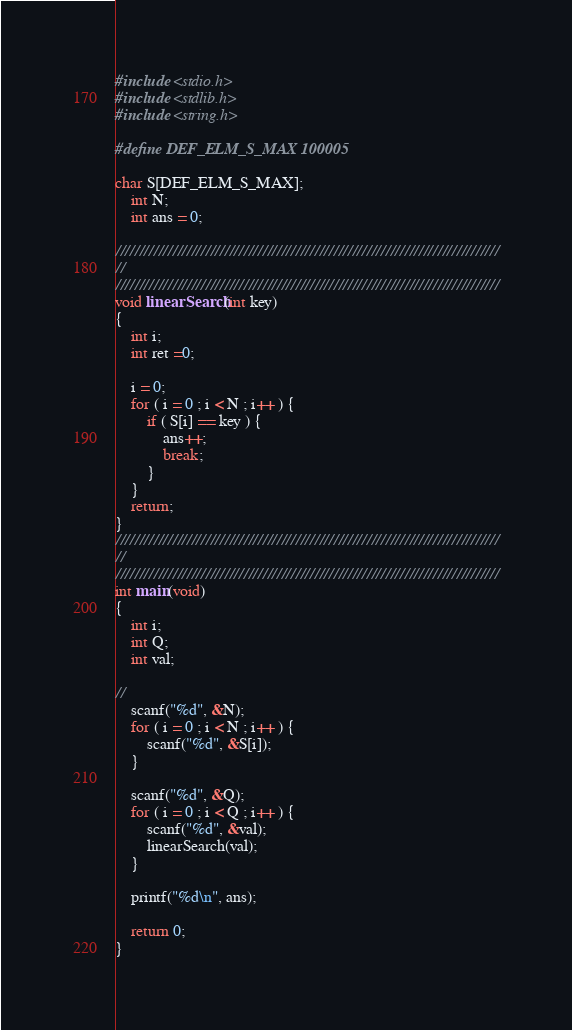<code> <loc_0><loc_0><loc_500><loc_500><_C_>#include <stdio.h>
#include <stdlib.h>
#include <string.h>

#define DEF_ELM_S_MAX 100005

char S[DEF_ELM_S_MAX];
	int N;
	int ans = 0;

/////////////////////////////////////////////////////////////////////////////////
//
/////////////////////////////////////////////////////////////////////////////////
void linearSearch(int key)
{
	int i;
	int ret =0;

	i = 0;
	for ( i = 0 ; i < N ; i++ ) {
		if ( S[i] == key ) {
			ans++;
			break;
		}
	}
	return;
}
/////////////////////////////////////////////////////////////////////////////////
//
/////////////////////////////////////////////////////////////////////////////////
int main(void)
{
	int i;
	int Q;
	int val;

//
	scanf("%d", &N);
	for ( i = 0 ; i < N ; i++ ) {
		scanf("%d", &S[i]);
	}

	scanf("%d", &Q);
	for ( i = 0 ; i < Q ; i++ ) {
		scanf("%d", &val);
		linearSearch(val);
	}

	printf("%d\n", ans);

	return 0;
}</code> 